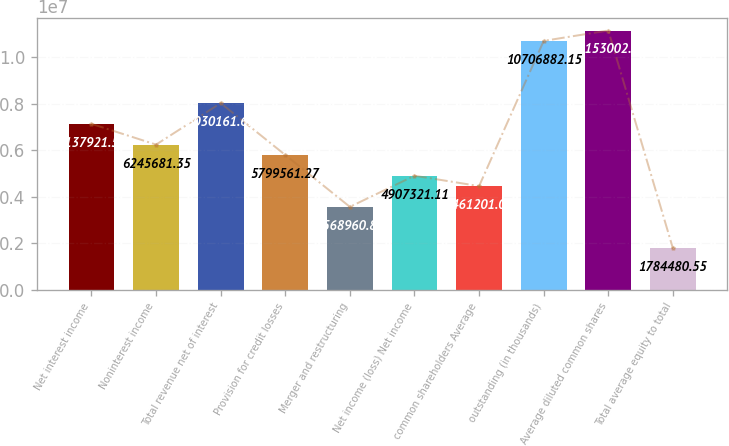Convert chart. <chart><loc_0><loc_0><loc_500><loc_500><bar_chart><fcel>Net interest income<fcel>Noninterest income<fcel>Total revenue net of interest<fcel>Provision for credit losses<fcel>Merger and restructuring<fcel>Net income (loss) Net income<fcel>common shareholders Average<fcel>outstanding (in thousands)<fcel>Average diluted common shares<fcel>Total average equity to total<nl><fcel>7.13792e+06<fcel>6.24568e+06<fcel>8.03016e+06<fcel>5.79956e+06<fcel>3.56896e+06<fcel>4.90732e+06<fcel>4.4612e+06<fcel>1.07069e+07<fcel>1.1153e+07<fcel>1.78448e+06<nl></chart> 